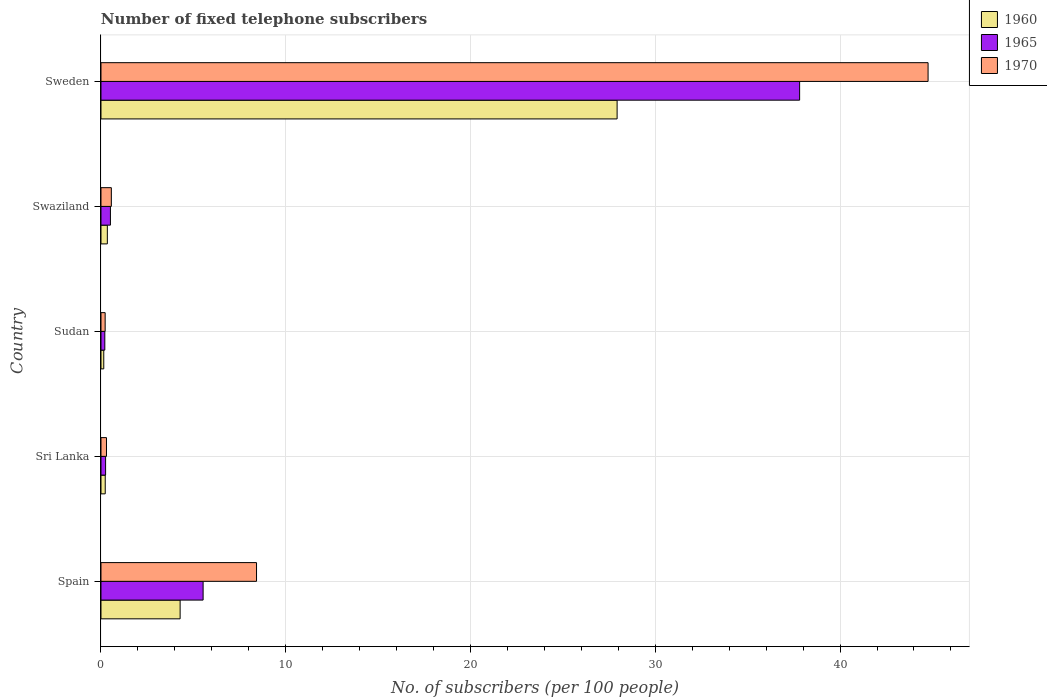How many bars are there on the 3rd tick from the bottom?
Give a very brief answer. 3. What is the label of the 2nd group of bars from the top?
Provide a short and direct response. Swaziland. In how many cases, is the number of bars for a given country not equal to the number of legend labels?
Keep it short and to the point. 0. What is the number of fixed telephone subscribers in 1965 in Sri Lanka?
Your answer should be very brief. 0.25. Across all countries, what is the maximum number of fixed telephone subscribers in 1970?
Provide a succinct answer. 44.76. Across all countries, what is the minimum number of fixed telephone subscribers in 1970?
Make the answer very short. 0.23. In which country was the number of fixed telephone subscribers in 1970 minimum?
Offer a very short reply. Sudan. What is the total number of fixed telephone subscribers in 1970 in the graph?
Offer a very short reply. 54.26. What is the difference between the number of fixed telephone subscribers in 1970 in Swaziland and that in Sweden?
Your response must be concise. -44.2. What is the difference between the number of fixed telephone subscribers in 1965 in Spain and the number of fixed telephone subscribers in 1970 in Sweden?
Keep it short and to the point. -39.24. What is the average number of fixed telephone subscribers in 1970 per country?
Give a very brief answer. 10.85. What is the difference between the number of fixed telephone subscribers in 1965 and number of fixed telephone subscribers in 1960 in Sudan?
Give a very brief answer. 0.06. What is the ratio of the number of fixed telephone subscribers in 1970 in Sri Lanka to that in Sudan?
Your answer should be compact. 1.32. Is the number of fixed telephone subscribers in 1960 in Sri Lanka less than that in Swaziland?
Your answer should be compact. Yes. What is the difference between the highest and the second highest number of fixed telephone subscribers in 1970?
Make the answer very short. 36.34. What is the difference between the highest and the lowest number of fixed telephone subscribers in 1965?
Offer a very short reply. 37.6. Is the sum of the number of fixed telephone subscribers in 1970 in Spain and Sri Lanka greater than the maximum number of fixed telephone subscribers in 1965 across all countries?
Your answer should be compact. No. What is the difference between two consecutive major ticks on the X-axis?
Offer a very short reply. 10. Does the graph contain any zero values?
Offer a terse response. No. Where does the legend appear in the graph?
Your response must be concise. Top right. How many legend labels are there?
Give a very brief answer. 3. How are the legend labels stacked?
Make the answer very short. Vertical. What is the title of the graph?
Your answer should be very brief. Number of fixed telephone subscribers. Does "1983" appear as one of the legend labels in the graph?
Your answer should be very brief. No. What is the label or title of the X-axis?
Your response must be concise. No. of subscribers (per 100 people). What is the label or title of the Y-axis?
Offer a very short reply. Country. What is the No. of subscribers (per 100 people) in 1960 in Spain?
Your response must be concise. 4.28. What is the No. of subscribers (per 100 people) in 1965 in Spain?
Provide a short and direct response. 5.53. What is the No. of subscribers (per 100 people) in 1970 in Spain?
Your response must be concise. 8.42. What is the No. of subscribers (per 100 people) of 1960 in Sri Lanka?
Your answer should be compact. 0.23. What is the No. of subscribers (per 100 people) in 1965 in Sri Lanka?
Make the answer very short. 0.25. What is the No. of subscribers (per 100 people) in 1970 in Sri Lanka?
Provide a succinct answer. 0.3. What is the No. of subscribers (per 100 people) in 1960 in Sudan?
Offer a very short reply. 0.15. What is the No. of subscribers (per 100 people) of 1965 in Sudan?
Ensure brevity in your answer.  0.21. What is the No. of subscribers (per 100 people) in 1970 in Sudan?
Your answer should be compact. 0.23. What is the No. of subscribers (per 100 people) in 1960 in Swaziland?
Your answer should be very brief. 0.34. What is the No. of subscribers (per 100 people) in 1965 in Swaziland?
Provide a succinct answer. 0.51. What is the No. of subscribers (per 100 people) of 1970 in Swaziland?
Your response must be concise. 0.56. What is the No. of subscribers (per 100 people) of 1960 in Sweden?
Offer a terse response. 27.93. What is the No. of subscribers (per 100 people) of 1965 in Sweden?
Make the answer very short. 37.81. What is the No. of subscribers (per 100 people) of 1970 in Sweden?
Give a very brief answer. 44.76. Across all countries, what is the maximum No. of subscribers (per 100 people) in 1960?
Offer a very short reply. 27.93. Across all countries, what is the maximum No. of subscribers (per 100 people) of 1965?
Make the answer very short. 37.81. Across all countries, what is the maximum No. of subscribers (per 100 people) in 1970?
Offer a very short reply. 44.76. Across all countries, what is the minimum No. of subscribers (per 100 people) in 1960?
Your answer should be compact. 0.15. Across all countries, what is the minimum No. of subscribers (per 100 people) in 1965?
Your response must be concise. 0.21. Across all countries, what is the minimum No. of subscribers (per 100 people) of 1970?
Your answer should be very brief. 0.23. What is the total No. of subscribers (per 100 people) of 1960 in the graph?
Make the answer very short. 32.94. What is the total No. of subscribers (per 100 people) in 1965 in the graph?
Offer a terse response. 44.31. What is the total No. of subscribers (per 100 people) in 1970 in the graph?
Ensure brevity in your answer.  54.26. What is the difference between the No. of subscribers (per 100 people) in 1960 in Spain and that in Sri Lanka?
Give a very brief answer. 4.05. What is the difference between the No. of subscribers (per 100 people) of 1965 in Spain and that in Sri Lanka?
Keep it short and to the point. 5.28. What is the difference between the No. of subscribers (per 100 people) of 1970 in Spain and that in Sri Lanka?
Keep it short and to the point. 8.12. What is the difference between the No. of subscribers (per 100 people) in 1960 in Spain and that in Sudan?
Make the answer very short. 4.13. What is the difference between the No. of subscribers (per 100 people) in 1965 in Spain and that in Sudan?
Your response must be concise. 5.32. What is the difference between the No. of subscribers (per 100 people) of 1970 in Spain and that in Sudan?
Provide a short and direct response. 8.19. What is the difference between the No. of subscribers (per 100 people) in 1960 in Spain and that in Swaziland?
Make the answer very short. 3.94. What is the difference between the No. of subscribers (per 100 people) of 1965 in Spain and that in Swaziland?
Give a very brief answer. 5.02. What is the difference between the No. of subscribers (per 100 people) in 1970 in Spain and that in Swaziland?
Offer a very short reply. 7.86. What is the difference between the No. of subscribers (per 100 people) in 1960 in Spain and that in Sweden?
Offer a very short reply. -23.65. What is the difference between the No. of subscribers (per 100 people) of 1965 in Spain and that in Sweden?
Keep it short and to the point. -32.28. What is the difference between the No. of subscribers (per 100 people) of 1970 in Spain and that in Sweden?
Keep it short and to the point. -36.34. What is the difference between the No. of subscribers (per 100 people) in 1960 in Sri Lanka and that in Sudan?
Provide a succinct answer. 0.08. What is the difference between the No. of subscribers (per 100 people) of 1965 in Sri Lanka and that in Sudan?
Your answer should be compact. 0.04. What is the difference between the No. of subscribers (per 100 people) in 1970 in Sri Lanka and that in Sudan?
Offer a terse response. 0.07. What is the difference between the No. of subscribers (per 100 people) in 1960 in Sri Lanka and that in Swaziland?
Your response must be concise. -0.11. What is the difference between the No. of subscribers (per 100 people) of 1965 in Sri Lanka and that in Swaziland?
Ensure brevity in your answer.  -0.26. What is the difference between the No. of subscribers (per 100 people) of 1970 in Sri Lanka and that in Swaziland?
Offer a terse response. -0.26. What is the difference between the No. of subscribers (per 100 people) of 1960 in Sri Lanka and that in Sweden?
Give a very brief answer. -27.7. What is the difference between the No. of subscribers (per 100 people) of 1965 in Sri Lanka and that in Sweden?
Your answer should be compact. -37.56. What is the difference between the No. of subscribers (per 100 people) of 1970 in Sri Lanka and that in Sweden?
Provide a short and direct response. -44.47. What is the difference between the No. of subscribers (per 100 people) in 1960 in Sudan and that in Swaziland?
Offer a terse response. -0.19. What is the difference between the No. of subscribers (per 100 people) in 1965 in Sudan and that in Swaziland?
Provide a succinct answer. -0.3. What is the difference between the No. of subscribers (per 100 people) in 1970 in Sudan and that in Swaziland?
Offer a terse response. -0.34. What is the difference between the No. of subscribers (per 100 people) of 1960 in Sudan and that in Sweden?
Give a very brief answer. -27.78. What is the difference between the No. of subscribers (per 100 people) in 1965 in Sudan and that in Sweden?
Offer a terse response. -37.6. What is the difference between the No. of subscribers (per 100 people) of 1970 in Sudan and that in Sweden?
Your answer should be compact. -44.54. What is the difference between the No. of subscribers (per 100 people) of 1960 in Swaziland and that in Sweden?
Offer a terse response. -27.59. What is the difference between the No. of subscribers (per 100 people) of 1965 in Swaziland and that in Sweden?
Make the answer very short. -37.3. What is the difference between the No. of subscribers (per 100 people) in 1970 in Swaziland and that in Sweden?
Make the answer very short. -44.2. What is the difference between the No. of subscribers (per 100 people) in 1960 in Spain and the No. of subscribers (per 100 people) in 1965 in Sri Lanka?
Give a very brief answer. 4.03. What is the difference between the No. of subscribers (per 100 people) in 1960 in Spain and the No. of subscribers (per 100 people) in 1970 in Sri Lanka?
Offer a very short reply. 3.99. What is the difference between the No. of subscribers (per 100 people) in 1965 in Spain and the No. of subscribers (per 100 people) in 1970 in Sri Lanka?
Ensure brevity in your answer.  5.23. What is the difference between the No. of subscribers (per 100 people) in 1960 in Spain and the No. of subscribers (per 100 people) in 1965 in Sudan?
Provide a succinct answer. 4.08. What is the difference between the No. of subscribers (per 100 people) of 1960 in Spain and the No. of subscribers (per 100 people) of 1970 in Sudan?
Your response must be concise. 4.06. What is the difference between the No. of subscribers (per 100 people) in 1965 in Spain and the No. of subscribers (per 100 people) in 1970 in Sudan?
Offer a terse response. 5.3. What is the difference between the No. of subscribers (per 100 people) in 1960 in Spain and the No. of subscribers (per 100 people) in 1965 in Swaziland?
Provide a short and direct response. 3.77. What is the difference between the No. of subscribers (per 100 people) of 1960 in Spain and the No. of subscribers (per 100 people) of 1970 in Swaziland?
Offer a terse response. 3.72. What is the difference between the No. of subscribers (per 100 people) of 1965 in Spain and the No. of subscribers (per 100 people) of 1970 in Swaziland?
Make the answer very short. 4.97. What is the difference between the No. of subscribers (per 100 people) of 1960 in Spain and the No. of subscribers (per 100 people) of 1965 in Sweden?
Make the answer very short. -33.53. What is the difference between the No. of subscribers (per 100 people) of 1960 in Spain and the No. of subscribers (per 100 people) of 1970 in Sweden?
Give a very brief answer. -40.48. What is the difference between the No. of subscribers (per 100 people) of 1965 in Spain and the No. of subscribers (per 100 people) of 1970 in Sweden?
Give a very brief answer. -39.24. What is the difference between the No. of subscribers (per 100 people) in 1960 in Sri Lanka and the No. of subscribers (per 100 people) in 1965 in Sudan?
Ensure brevity in your answer.  0.02. What is the difference between the No. of subscribers (per 100 people) of 1960 in Sri Lanka and the No. of subscribers (per 100 people) of 1970 in Sudan?
Provide a short and direct response. 0. What is the difference between the No. of subscribers (per 100 people) of 1965 in Sri Lanka and the No. of subscribers (per 100 people) of 1970 in Sudan?
Offer a terse response. 0.02. What is the difference between the No. of subscribers (per 100 people) in 1960 in Sri Lanka and the No. of subscribers (per 100 people) in 1965 in Swaziland?
Your response must be concise. -0.28. What is the difference between the No. of subscribers (per 100 people) of 1960 in Sri Lanka and the No. of subscribers (per 100 people) of 1970 in Swaziland?
Give a very brief answer. -0.33. What is the difference between the No. of subscribers (per 100 people) of 1965 in Sri Lanka and the No. of subscribers (per 100 people) of 1970 in Swaziland?
Your answer should be compact. -0.31. What is the difference between the No. of subscribers (per 100 people) of 1960 in Sri Lanka and the No. of subscribers (per 100 people) of 1965 in Sweden?
Provide a short and direct response. -37.58. What is the difference between the No. of subscribers (per 100 people) of 1960 in Sri Lanka and the No. of subscribers (per 100 people) of 1970 in Sweden?
Your response must be concise. -44.53. What is the difference between the No. of subscribers (per 100 people) of 1965 in Sri Lanka and the No. of subscribers (per 100 people) of 1970 in Sweden?
Make the answer very short. -44.51. What is the difference between the No. of subscribers (per 100 people) of 1960 in Sudan and the No. of subscribers (per 100 people) of 1965 in Swaziland?
Make the answer very short. -0.36. What is the difference between the No. of subscribers (per 100 people) of 1960 in Sudan and the No. of subscribers (per 100 people) of 1970 in Swaziland?
Your answer should be compact. -0.41. What is the difference between the No. of subscribers (per 100 people) of 1965 in Sudan and the No. of subscribers (per 100 people) of 1970 in Swaziland?
Your answer should be very brief. -0.35. What is the difference between the No. of subscribers (per 100 people) of 1960 in Sudan and the No. of subscribers (per 100 people) of 1965 in Sweden?
Offer a terse response. -37.66. What is the difference between the No. of subscribers (per 100 people) of 1960 in Sudan and the No. of subscribers (per 100 people) of 1970 in Sweden?
Make the answer very short. -44.61. What is the difference between the No. of subscribers (per 100 people) of 1965 in Sudan and the No. of subscribers (per 100 people) of 1970 in Sweden?
Offer a very short reply. -44.56. What is the difference between the No. of subscribers (per 100 people) in 1960 in Swaziland and the No. of subscribers (per 100 people) in 1965 in Sweden?
Make the answer very short. -37.47. What is the difference between the No. of subscribers (per 100 people) of 1960 in Swaziland and the No. of subscribers (per 100 people) of 1970 in Sweden?
Offer a terse response. -44.42. What is the difference between the No. of subscribers (per 100 people) in 1965 in Swaziland and the No. of subscribers (per 100 people) in 1970 in Sweden?
Your answer should be very brief. -44.25. What is the average No. of subscribers (per 100 people) of 1960 per country?
Ensure brevity in your answer.  6.59. What is the average No. of subscribers (per 100 people) in 1965 per country?
Offer a terse response. 8.86. What is the average No. of subscribers (per 100 people) in 1970 per country?
Give a very brief answer. 10.85. What is the difference between the No. of subscribers (per 100 people) of 1960 and No. of subscribers (per 100 people) of 1965 in Spain?
Give a very brief answer. -1.24. What is the difference between the No. of subscribers (per 100 people) of 1960 and No. of subscribers (per 100 people) of 1970 in Spain?
Keep it short and to the point. -4.14. What is the difference between the No. of subscribers (per 100 people) in 1965 and No. of subscribers (per 100 people) in 1970 in Spain?
Your response must be concise. -2.89. What is the difference between the No. of subscribers (per 100 people) of 1960 and No. of subscribers (per 100 people) of 1965 in Sri Lanka?
Your response must be concise. -0.02. What is the difference between the No. of subscribers (per 100 people) of 1960 and No. of subscribers (per 100 people) of 1970 in Sri Lanka?
Offer a terse response. -0.07. What is the difference between the No. of subscribers (per 100 people) of 1965 and No. of subscribers (per 100 people) of 1970 in Sri Lanka?
Your answer should be very brief. -0.05. What is the difference between the No. of subscribers (per 100 people) in 1960 and No. of subscribers (per 100 people) in 1965 in Sudan?
Ensure brevity in your answer.  -0.06. What is the difference between the No. of subscribers (per 100 people) in 1960 and No. of subscribers (per 100 people) in 1970 in Sudan?
Ensure brevity in your answer.  -0.08. What is the difference between the No. of subscribers (per 100 people) of 1965 and No. of subscribers (per 100 people) of 1970 in Sudan?
Offer a terse response. -0.02. What is the difference between the No. of subscribers (per 100 people) of 1960 and No. of subscribers (per 100 people) of 1965 in Swaziland?
Offer a very short reply. -0.17. What is the difference between the No. of subscribers (per 100 people) of 1960 and No. of subscribers (per 100 people) of 1970 in Swaziland?
Offer a terse response. -0.22. What is the difference between the No. of subscribers (per 100 people) of 1965 and No. of subscribers (per 100 people) of 1970 in Swaziland?
Offer a very short reply. -0.05. What is the difference between the No. of subscribers (per 100 people) of 1960 and No. of subscribers (per 100 people) of 1965 in Sweden?
Your response must be concise. -9.88. What is the difference between the No. of subscribers (per 100 people) of 1960 and No. of subscribers (per 100 people) of 1970 in Sweden?
Your answer should be very brief. -16.83. What is the difference between the No. of subscribers (per 100 people) in 1965 and No. of subscribers (per 100 people) in 1970 in Sweden?
Provide a succinct answer. -6.95. What is the ratio of the No. of subscribers (per 100 people) in 1960 in Spain to that in Sri Lanka?
Offer a terse response. 18.61. What is the ratio of the No. of subscribers (per 100 people) of 1965 in Spain to that in Sri Lanka?
Ensure brevity in your answer.  22.18. What is the ratio of the No. of subscribers (per 100 people) of 1970 in Spain to that in Sri Lanka?
Your response must be concise. 28.33. What is the ratio of the No. of subscribers (per 100 people) of 1960 in Spain to that in Sudan?
Offer a terse response. 28.56. What is the ratio of the No. of subscribers (per 100 people) in 1965 in Spain to that in Sudan?
Your response must be concise. 26.65. What is the ratio of the No. of subscribers (per 100 people) of 1970 in Spain to that in Sudan?
Give a very brief answer. 37.33. What is the ratio of the No. of subscribers (per 100 people) in 1960 in Spain to that in Swaziland?
Make the answer very short. 12.46. What is the ratio of the No. of subscribers (per 100 people) in 1965 in Spain to that in Swaziland?
Your response must be concise. 10.82. What is the ratio of the No. of subscribers (per 100 people) in 1970 in Spain to that in Swaziland?
Your response must be concise. 15.01. What is the ratio of the No. of subscribers (per 100 people) in 1960 in Spain to that in Sweden?
Offer a very short reply. 0.15. What is the ratio of the No. of subscribers (per 100 people) of 1965 in Spain to that in Sweden?
Make the answer very short. 0.15. What is the ratio of the No. of subscribers (per 100 people) in 1970 in Spain to that in Sweden?
Provide a succinct answer. 0.19. What is the ratio of the No. of subscribers (per 100 people) of 1960 in Sri Lanka to that in Sudan?
Provide a short and direct response. 1.53. What is the ratio of the No. of subscribers (per 100 people) of 1965 in Sri Lanka to that in Sudan?
Provide a short and direct response. 1.2. What is the ratio of the No. of subscribers (per 100 people) in 1970 in Sri Lanka to that in Sudan?
Provide a succinct answer. 1.32. What is the ratio of the No. of subscribers (per 100 people) in 1960 in Sri Lanka to that in Swaziland?
Offer a terse response. 0.67. What is the ratio of the No. of subscribers (per 100 people) of 1965 in Sri Lanka to that in Swaziland?
Offer a very short reply. 0.49. What is the ratio of the No. of subscribers (per 100 people) of 1970 in Sri Lanka to that in Swaziland?
Offer a terse response. 0.53. What is the ratio of the No. of subscribers (per 100 people) of 1960 in Sri Lanka to that in Sweden?
Give a very brief answer. 0.01. What is the ratio of the No. of subscribers (per 100 people) of 1965 in Sri Lanka to that in Sweden?
Provide a succinct answer. 0.01. What is the ratio of the No. of subscribers (per 100 people) in 1970 in Sri Lanka to that in Sweden?
Give a very brief answer. 0.01. What is the ratio of the No. of subscribers (per 100 people) of 1960 in Sudan to that in Swaziland?
Offer a terse response. 0.44. What is the ratio of the No. of subscribers (per 100 people) of 1965 in Sudan to that in Swaziland?
Give a very brief answer. 0.41. What is the ratio of the No. of subscribers (per 100 people) in 1970 in Sudan to that in Swaziland?
Provide a short and direct response. 0.4. What is the ratio of the No. of subscribers (per 100 people) in 1960 in Sudan to that in Sweden?
Make the answer very short. 0.01. What is the ratio of the No. of subscribers (per 100 people) in 1965 in Sudan to that in Sweden?
Provide a succinct answer. 0.01. What is the ratio of the No. of subscribers (per 100 people) in 1970 in Sudan to that in Sweden?
Offer a very short reply. 0.01. What is the ratio of the No. of subscribers (per 100 people) in 1960 in Swaziland to that in Sweden?
Give a very brief answer. 0.01. What is the ratio of the No. of subscribers (per 100 people) in 1965 in Swaziland to that in Sweden?
Keep it short and to the point. 0.01. What is the ratio of the No. of subscribers (per 100 people) in 1970 in Swaziland to that in Sweden?
Offer a terse response. 0.01. What is the difference between the highest and the second highest No. of subscribers (per 100 people) in 1960?
Keep it short and to the point. 23.65. What is the difference between the highest and the second highest No. of subscribers (per 100 people) in 1965?
Give a very brief answer. 32.28. What is the difference between the highest and the second highest No. of subscribers (per 100 people) of 1970?
Give a very brief answer. 36.34. What is the difference between the highest and the lowest No. of subscribers (per 100 people) in 1960?
Make the answer very short. 27.78. What is the difference between the highest and the lowest No. of subscribers (per 100 people) in 1965?
Your answer should be compact. 37.6. What is the difference between the highest and the lowest No. of subscribers (per 100 people) of 1970?
Ensure brevity in your answer.  44.54. 